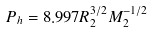Convert formula to latex. <formula><loc_0><loc_0><loc_500><loc_500>P _ { h } = 8 . 9 9 7 R _ { 2 } ^ { 3 / 2 } M _ { 2 } ^ { - 1 / 2 }</formula> 